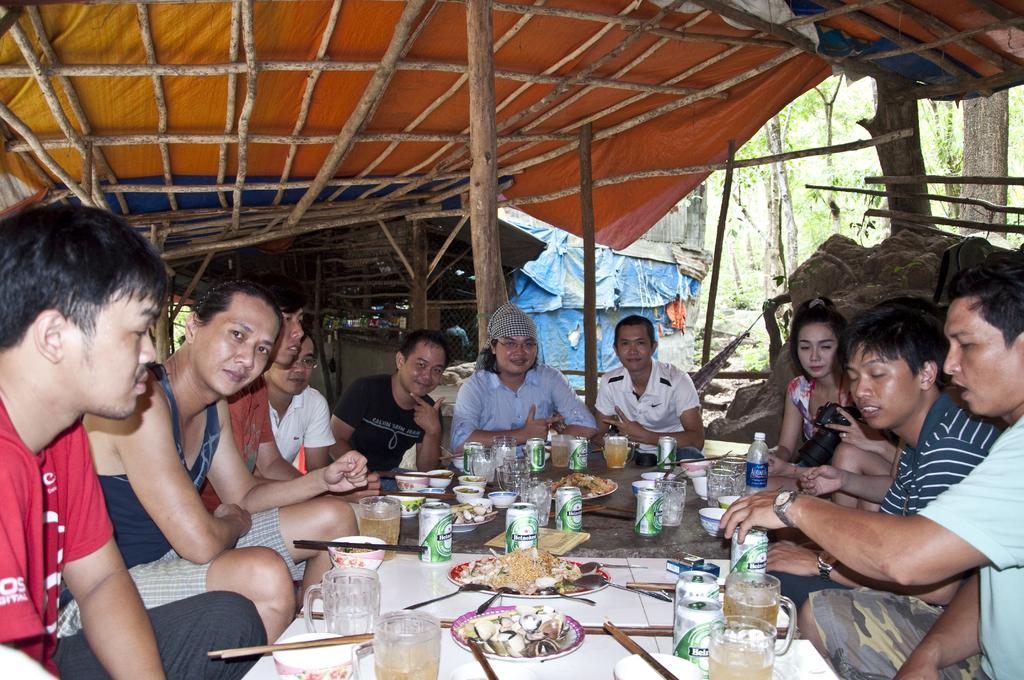Describe this image in one or two sentences. This is a picture taken under a tent maybe in a forest. In the picture there are people seated around a table, on the table there are glasses, tins, plates, bowls, chopsticks and food items are there. On the top right there are trees. In the center of the background there is a tent. On the top there are wooden sticks. 